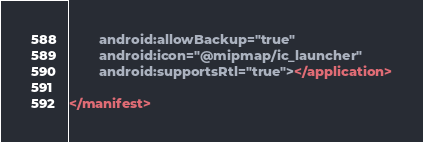Convert code to text. <code><loc_0><loc_0><loc_500><loc_500><_XML_>        android:allowBackup="true"
        android:icon="@mipmap/ic_launcher"
        android:supportsRtl="true"></application>

</manifest></code> 